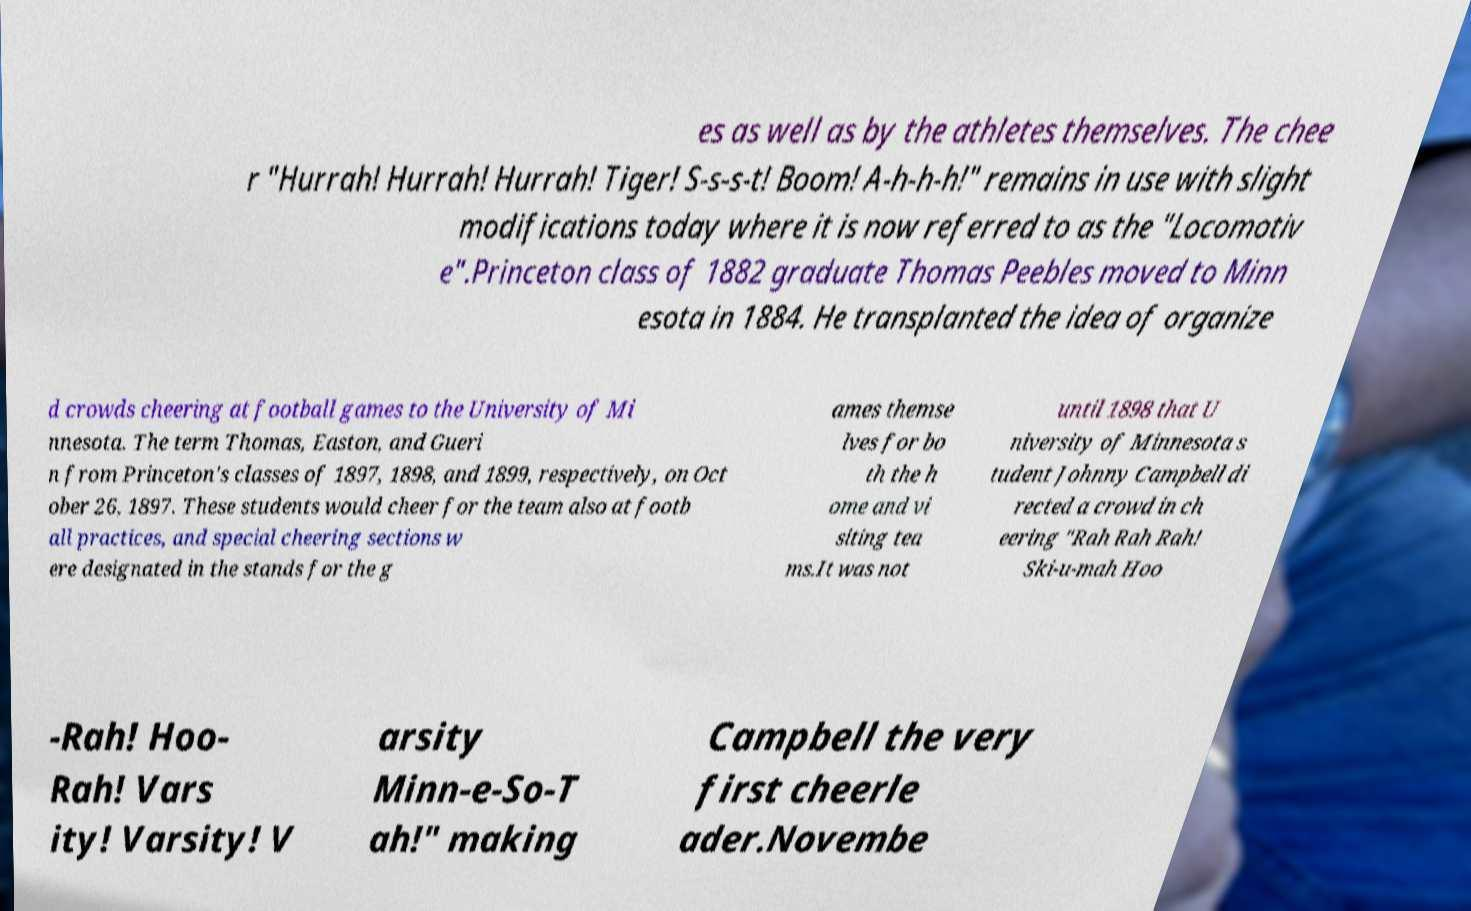I need the written content from this picture converted into text. Can you do that? es as well as by the athletes themselves. The chee r "Hurrah! Hurrah! Hurrah! Tiger! S-s-s-t! Boom! A-h-h-h!" remains in use with slight modifications today where it is now referred to as the "Locomotiv e".Princeton class of 1882 graduate Thomas Peebles moved to Minn esota in 1884. He transplanted the idea of organize d crowds cheering at football games to the University of Mi nnesota. The term Thomas, Easton, and Gueri n from Princeton's classes of 1897, 1898, and 1899, respectively, on Oct ober 26, 1897. These students would cheer for the team also at footb all practices, and special cheering sections w ere designated in the stands for the g ames themse lves for bo th the h ome and vi siting tea ms.It was not until 1898 that U niversity of Minnesota s tudent Johnny Campbell di rected a crowd in ch eering "Rah Rah Rah! Ski-u-mah Hoo -Rah! Hoo- Rah! Vars ity! Varsity! V arsity Minn-e-So-T ah!" making Campbell the very first cheerle ader.Novembe 